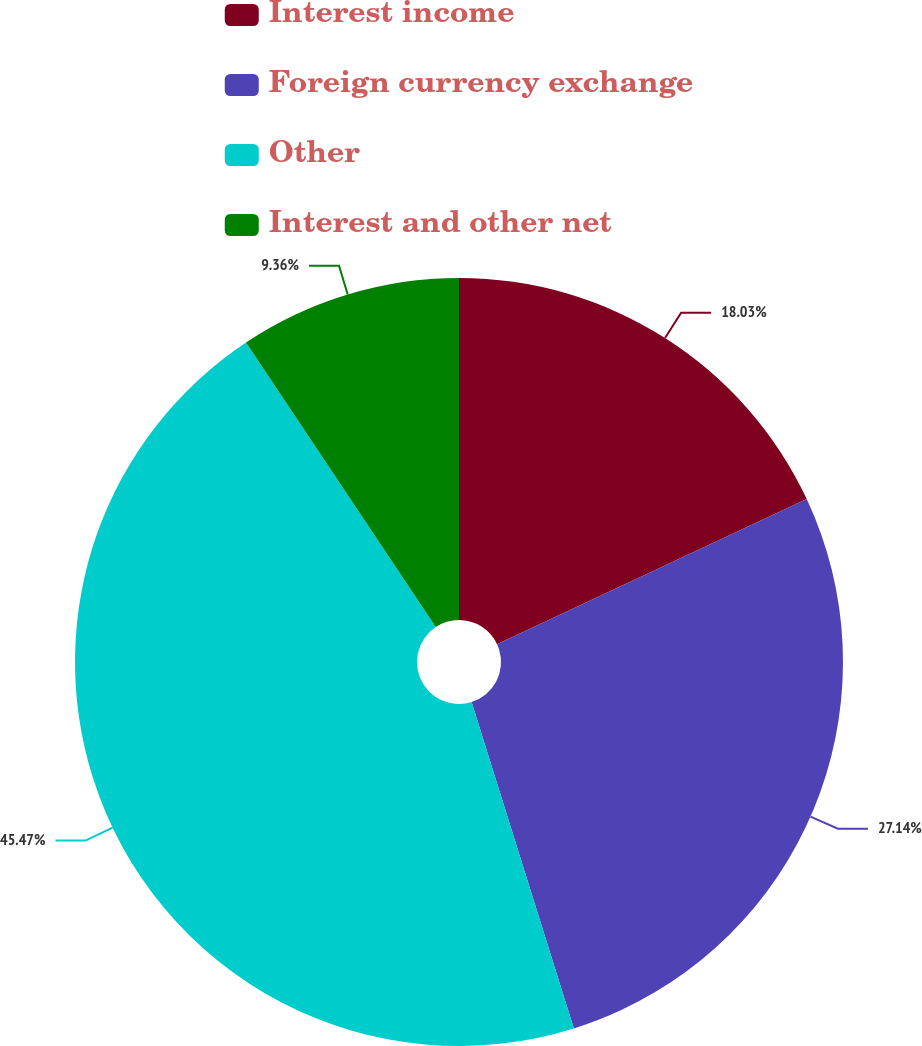Convert chart. <chart><loc_0><loc_0><loc_500><loc_500><pie_chart><fcel>Interest income<fcel>Foreign currency exchange<fcel>Other<fcel>Interest and other net<nl><fcel>18.03%<fcel>27.14%<fcel>45.48%<fcel>9.36%<nl></chart> 